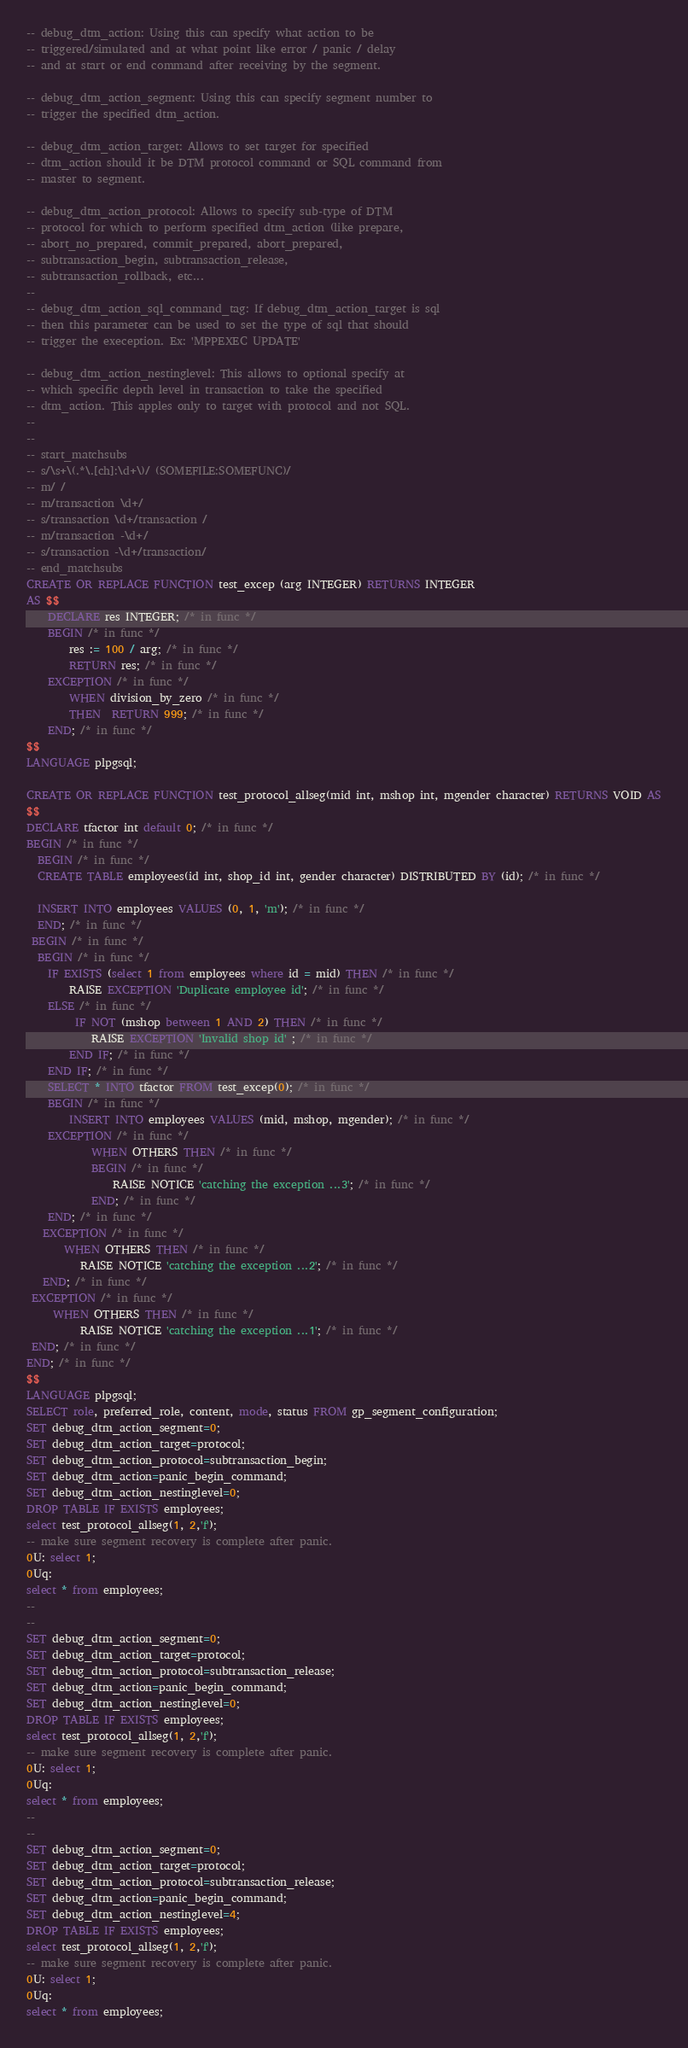Convert code to text. <code><loc_0><loc_0><loc_500><loc_500><_SQL_>-- debug_dtm_action: Using this can specify what action to be
-- triggered/simulated and at what point like error / panic / delay
-- and at start or end command after receiving by the segment.

-- debug_dtm_action_segment: Using this can specify segment number to
-- trigger the specified dtm_action.

-- debug_dtm_action_target: Allows to set target for specified
-- dtm_action should it be DTM protocol command or SQL command from
-- master to segment.

-- debug_dtm_action_protocol: Allows to specify sub-type of DTM
-- protocol for which to perform specified dtm_action (like prepare,
-- abort_no_prepared, commit_prepared, abort_prepared,
-- subtransaction_begin, subtransaction_release,
-- subtransaction_rollback, etc...
--
-- debug_dtm_action_sql_command_tag: If debug_dtm_action_target is sql
-- then this parameter can be used to set the type of sql that should
-- trigger the exeception. Ex: 'MPPEXEC UPDATE'

-- debug_dtm_action_nestinglevel: This allows to optional specify at
-- which specific depth level in transaction to take the specified
-- dtm_action. This apples only to target with protocol and not SQL.
--
--
-- start_matchsubs
-- s/\s+\(.*\.[ch]:\d+\)/ (SOMEFILE:SOMEFUNC)/
-- m/ /
-- m/transaction \d+/
-- s/transaction \d+/transaction /
-- m/transaction -\d+/
-- s/transaction -\d+/transaction/
-- end_matchsubs
CREATE OR REPLACE FUNCTION test_excep (arg INTEGER) RETURNS INTEGER
AS $$
    DECLARE res INTEGER; /* in func */
    BEGIN /* in func */
        res := 100 / arg; /* in func */
        RETURN res; /* in func */
    EXCEPTION /* in func */
        WHEN division_by_zero /* in func */
        THEN  RETURN 999; /* in func */
    END; /* in func */
$$
LANGUAGE plpgsql;

CREATE OR REPLACE FUNCTION test_protocol_allseg(mid int, mshop int, mgender character) RETURNS VOID AS
$$
DECLARE tfactor int default 0; /* in func */
BEGIN /* in func */
  BEGIN /* in func */
  CREATE TABLE employees(id int, shop_id int, gender character) DISTRIBUTED BY (id); /* in func */
  
  INSERT INTO employees VALUES (0, 1, 'm'); /* in func */
  END; /* in func */
 BEGIN /* in func */
  BEGIN /* in func */
    IF EXISTS (select 1 from employees where id = mid) THEN /* in func */
        RAISE EXCEPTION 'Duplicate employee id'; /* in func */
    ELSE /* in func */
         IF NOT (mshop between 1 AND 2) THEN /* in func */
            RAISE EXCEPTION 'Invalid shop id' ; /* in func */
        END IF; /* in func */
    END IF; /* in func */
    SELECT * INTO tfactor FROM test_excep(0); /* in func */
    BEGIN /* in func */
        INSERT INTO employees VALUES (mid, mshop, mgender); /* in func */
    EXCEPTION /* in func */
            WHEN OTHERS THEN /* in func */
            BEGIN /* in func */
                RAISE NOTICE 'catching the exception ...3'; /* in func */
            END; /* in func */
    END; /* in func */
   EXCEPTION /* in func */
       WHEN OTHERS THEN /* in func */
          RAISE NOTICE 'catching the exception ...2'; /* in func */
   END; /* in func */
 EXCEPTION /* in func */
     WHEN OTHERS THEN /* in func */
          RAISE NOTICE 'catching the exception ...1'; /* in func */
 END; /* in func */
END; /* in func */
$$
LANGUAGE plpgsql;
SELECT role, preferred_role, content, mode, status FROM gp_segment_configuration;
SET debug_dtm_action_segment=0;
SET debug_dtm_action_target=protocol;
SET debug_dtm_action_protocol=subtransaction_begin;
SET debug_dtm_action=panic_begin_command;
SET debug_dtm_action_nestinglevel=0;
DROP TABLE IF EXISTS employees;
select test_protocol_allseg(1, 2,'f');
-- make sure segment recovery is complete after panic.
0U: select 1;
0Uq:
select * from employees;
--
--
SET debug_dtm_action_segment=0;
SET debug_dtm_action_target=protocol;
SET debug_dtm_action_protocol=subtransaction_release;
SET debug_dtm_action=panic_begin_command;
SET debug_dtm_action_nestinglevel=0;
DROP TABLE IF EXISTS employees;
select test_protocol_allseg(1, 2,'f');
-- make sure segment recovery is complete after panic.
0U: select 1;
0Uq:
select * from employees;
--
--
SET debug_dtm_action_segment=0;
SET debug_dtm_action_target=protocol;
SET debug_dtm_action_protocol=subtransaction_release;
SET debug_dtm_action=panic_begin_command;
SET debug_dtm_action_nestinglevel=4;
DROP TABLE IF EXISTS employees;
select test_protocol_allseg(1, 2,'f');
-- make sure segment recovery is complete after panic.
0U: select 1;
0Uq:
select * from employees;</code> 